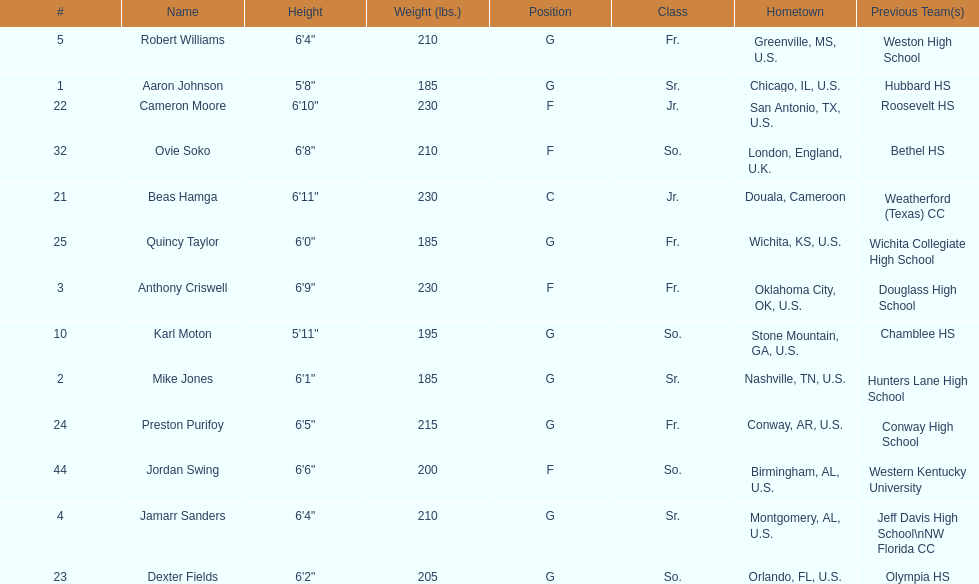What is the average weight of jamarr sanders and robert williams? 210. 